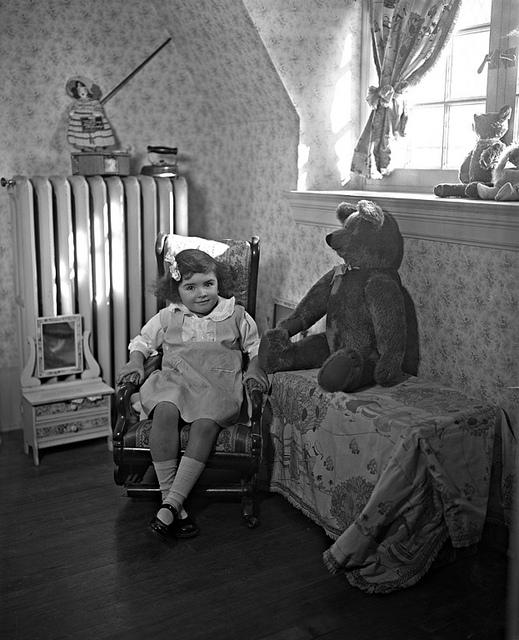What is the girl sitting on?
Give a very brief answer. Rocking chair. Where is the mirror?
Answer briefly. Behind girl. How many kids are sitting down?
Concise answer only. 1. What is on the small vanity table?
Keep it brief. Mirror. 